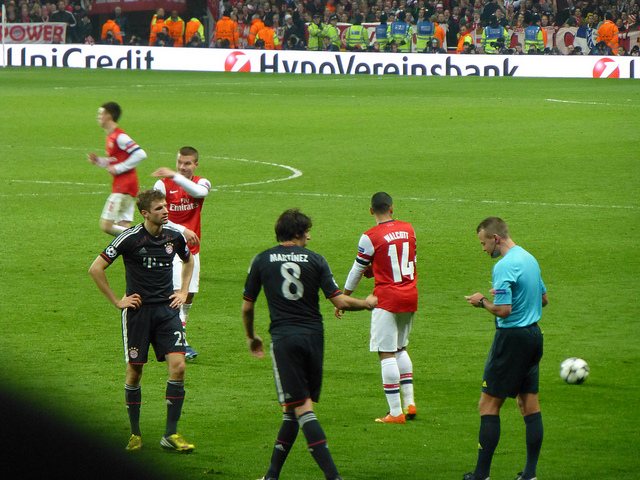<image>What teams are playing? I am not sure what teams are playing. It could be 'Spain and Mexico', 'Netherlands and Spain', 'Emirates and Arsenal', or a team in 'black and red' or 'red and black'. What teams are playing? I am not sure which teams are playing. It can be seen 'spain and mexico', 'black and red', 'soccer', 'red and black', 'emirates and arsenal', 'netherlands and spain'. 